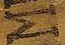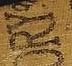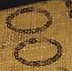What text is displayed in these images sequentially, separated by a semicolon? M; ORY; OO 